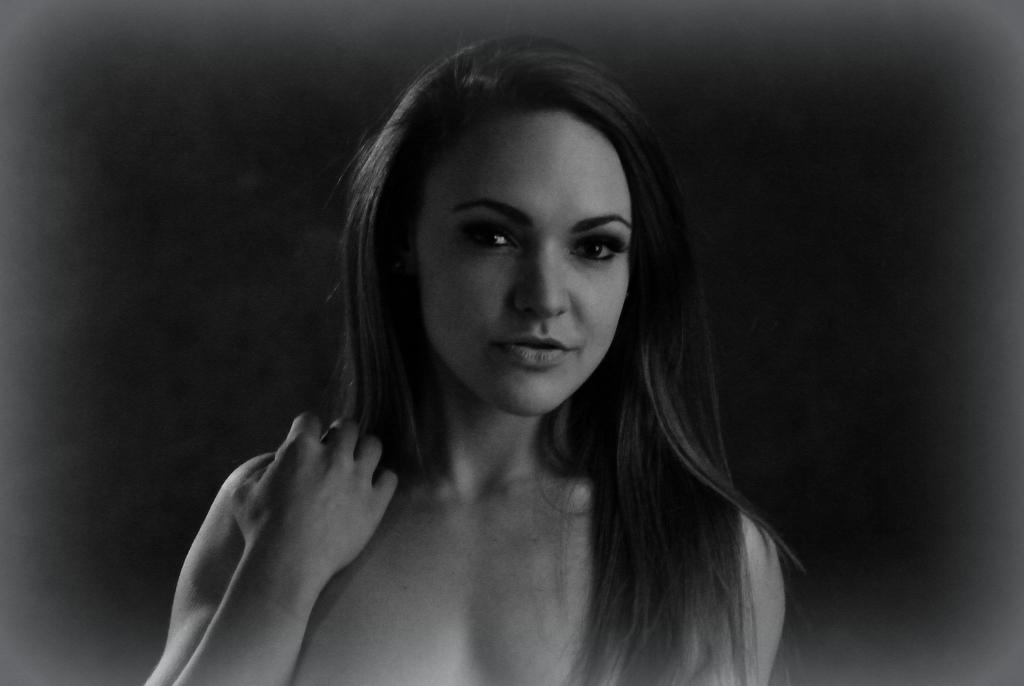Who is the main subject in the image? There is a lady in the center of the image. How many toes can be seen on the lady's feet in the image? There is no information about the lady's feet or toes in the provided fact, so we cannot answer this question. 